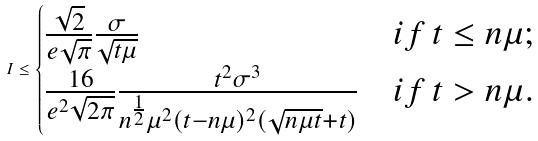Convert formula to latex. <formula><loc_0><loc_0><loc_500><loc_500>I \leq \begin{cases} \frac { \sqrt { 2 } } { e \sqrt { \pi } } \frac { \sigma } { \sqrt { t \mu } } & i f \, t \leq n \mu ; \\ \frac { 1 6 } { e ^ { 2 } \sqrt { 2 \pi } } \frac { { t ^ { 2 } } \sigma ^ { 3 } } { { n ^ { \frac { 1 } { 2 } } \mu ^ { 2 } } { ( t - n \mu ) ^ { 2 } ( \sqrt { n \mu t } + t ) } } & i f \, t > n \mu . \end{cases}</formula> 